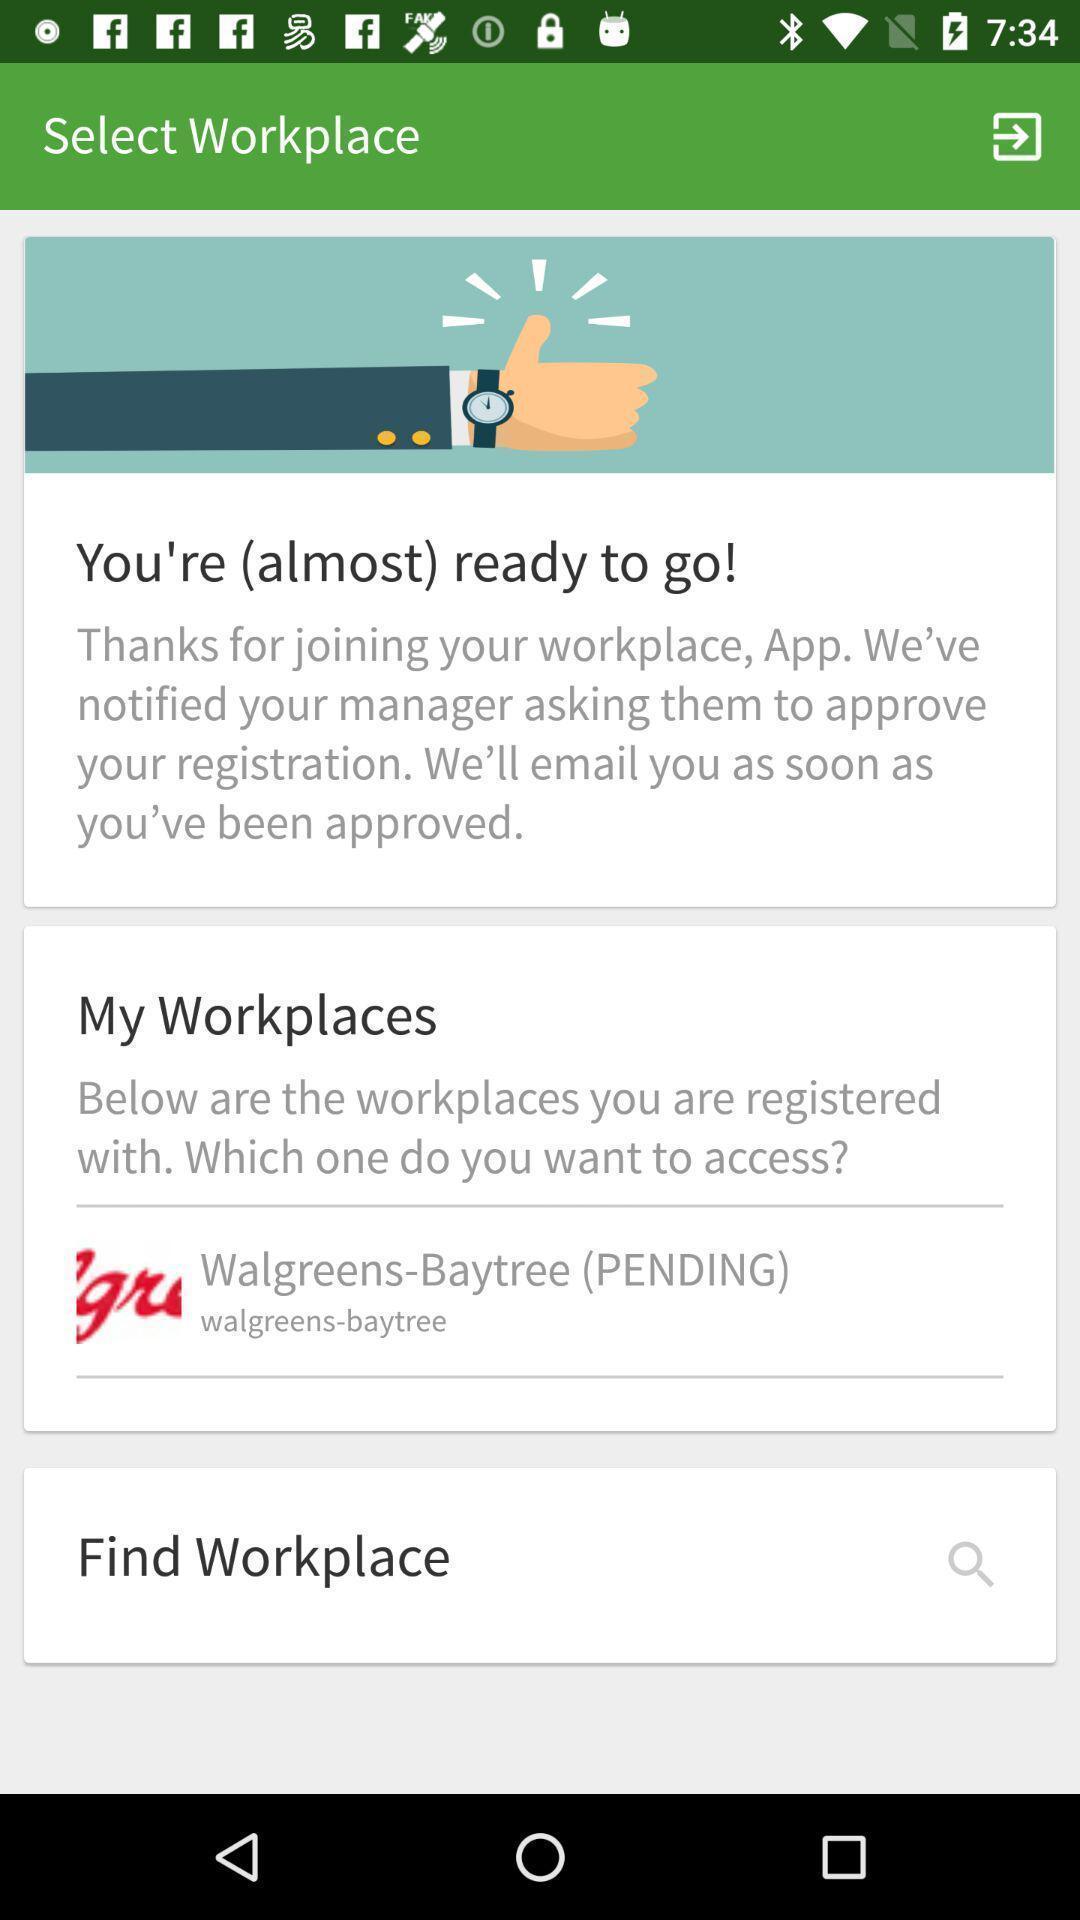Describe the content in this image. Workplace selection page of a employee schedule app. 